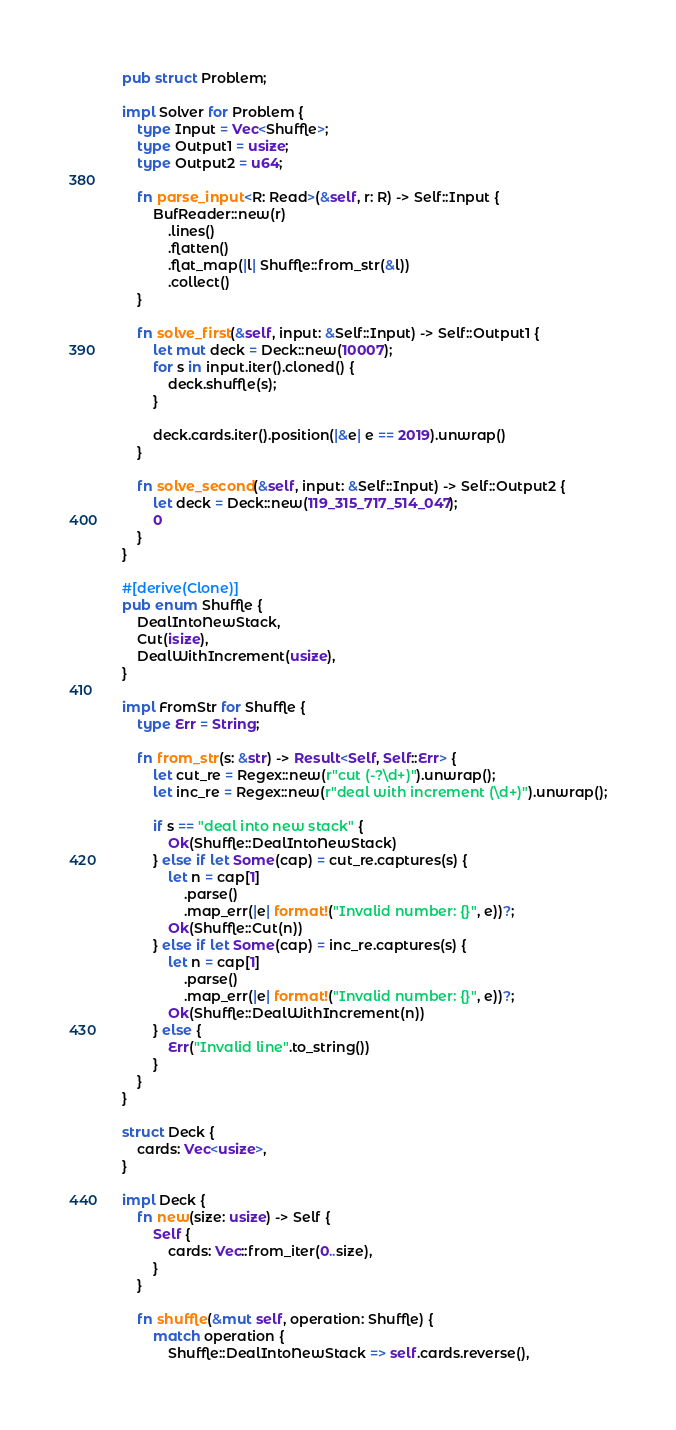<code> <loc_0><loc_0><loc_500><loc_500><_Rust_>pub struct Problem;

impl Solver for Problem {
    type Input = Vec<Shuffle>;
    type Output1 = usize;
    type Output2 = u64;

    fn parse_input<R: Read>(&self, r: R) -> Self::Input {
        BufReader::new(r)
            .lines()
            .flatten()
            .flat_map(|l| Shuffle::from_str(&l))
            .collect()
    }

    fn solve_first(&self, input: &Self::Input) -> Self::Output1 {
        let mut deck = Deck::new(10007);
        for s in input.iter().cloned() {
            deck.shuffle(s);
        }

        deck.cards.iter().position(|&e| e == 2019).unwrap()
    }

    fn solve_second(&self, input: &Self::Input) -> Self::Output2 {
        let deck = Deck::new(119_315_717_514_047);
        0
    }
}

#[derive(Clone)]
pub enum Shuffle {
    DealIntoNewStack,
    Cut(isize),
    DealWithIncrement(usize),
}

impl FromStr for Shuffle {
    type Err = String;

    fn from_str(s: &str) -> Result<Self, Self::Err> {
        let cut_re = Regex::new(r"cut (-?\d+)").unwrap();
        let inc_re = Regex::new(r"deal with increment (\d+)").unwrap();

        if s == "deal into new stack" {
            Ok(Shuffle::DealIntoNewStack)
        } else if let Some(cap) = cut_re.captures(s) {
            let n = cap[1]
                .parse()
                .map_err(|e| format!("Invalid number: {}", e))?;
            Ok(Shuffle::Cut(n))
        } else if let Some(cap) = inc_re.captures(s) {
            let n = cap[1]
                .parse()
                .map_err(|e| format!("Invalid number: {}", e))?;
            Ok(Shuffle::DealWithIncrement(n))
        } else {
            Err("Invalid line".to_string())
        }
    }
}

struct Deck {
    cards: Vec<usize>,
}

impl Deck {
    fn new(size: usize) -> Self {
        Self {
            cards: Vec::from_iter(0..size),
        }
    }

    fn shuffle(&mut self, operation: Shuffle) {
        match operation {
            Shuffle::DealIntoNewStack => self.cards.reverse(),</code> 